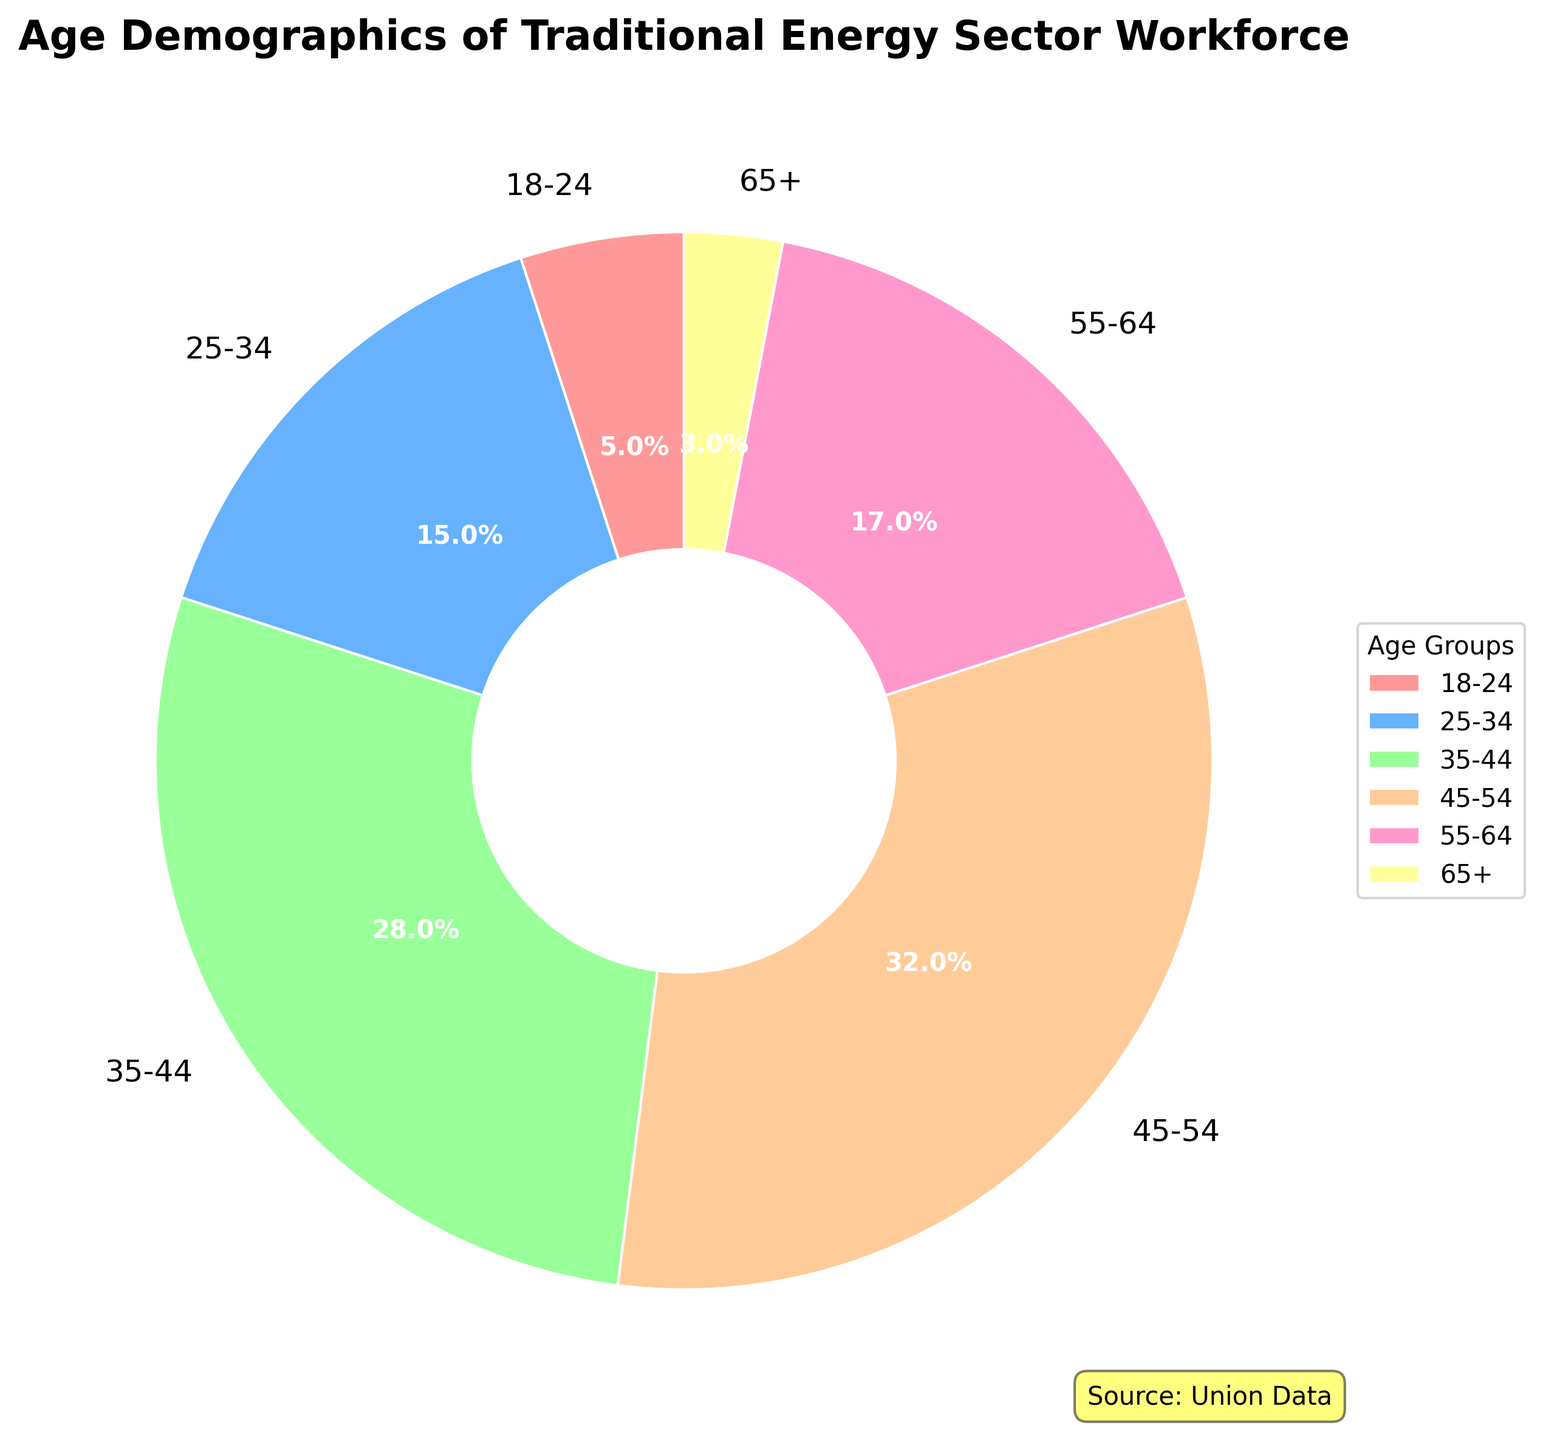Which age group has the highest percentage in the traditional energy sector workforce? By examining the pie chart, it's clear that the age group with the largest segment corresponds to the highest percentage. The age group 45-54 occupies the largest segment.
Answer: 45-54 Which two age groups combined account for more than half of the workforce? Summing up the percentages of different age groups helps identify that groups 35-44 (28%) and 45-54 (32%) together account for 60%, which is more than half of the workforce.
Answer: 35-44 and 45-54 What is the difference in percentage between the 25-34 and 55-64 age groups? By subtracting the percentage of the 55-64 age group (17%) from that of the 25-34 age group (15%), the difference is found to be -2%.
Answer: -2% Which age group has the smallest representation in the workforce, and what percentage do they hold? By observing the pie chart, the smallest segment corresponds to the age group 65+, which holds 3% of the workforce.
Answer: 65+, 3% How do the combined percentages of the youngest age group (18-24) and the oldest age group (65+) compare with the percentage of the 35-44 age group? Adding the percentages for 18-24 (5%) and 65+ (3%) results in 8%, which is less than the percentage of the 35-44 age group (28%).
Answer: 8% < 28% Which age group is represented by the color blue, and what is their percentage? By looking at the pie chart, the segment colored blue corresponds to the 25-34 age group, which holds a 15% representation.
Answer: 25-34, 15% What is the total percentage of the workforce that is aged 44 or younger? To find this, sum the percentages of the age groups 18-24 (5%), 25-34 (15%), and 35-44 (28%), resulting in 48%.
Answer: 48% If we sum the percentages of all age groups except for the largest one, what is the resulting total? Adding the percentages of age groups 18-24 (5%), 25-34 (15%), 35-44 (28%), 55-64 (17%), and 65+ (3%) results in a total of 68%, excluding the 45-54 group (32%).
Answer: 68% Which age group is closest in percentage to the overall average of the workforce distribution? The average percentage is calculated as the total (100%) divided by the number of age groups (6), equaling approximately 16.7%. The 55-64 age group, with 17%, is closest to this average.
Answer: 55-64, 17% What percentage of the workforce is older than 54? To find this, sum the percentages of the 55-64 (17%) and the 65+ (3%) age groups, resulting in 20%.
Answer: 20% 